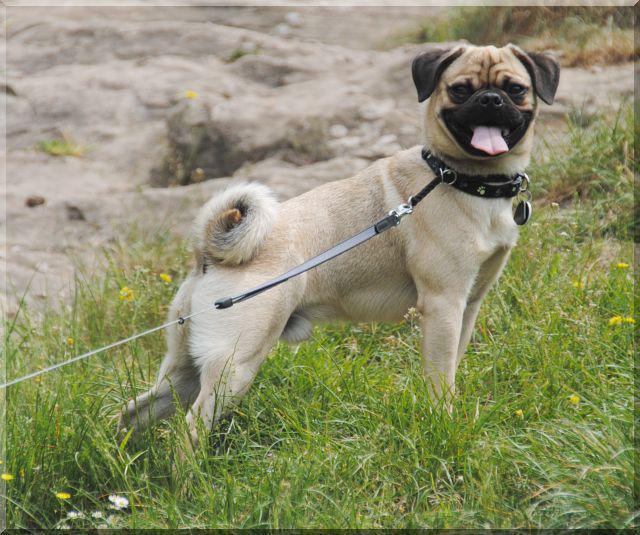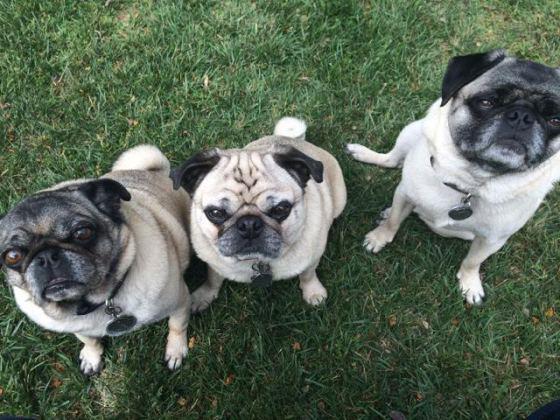The first image is the image on the left, the second image is the image on the right. Assess this claim about the two images: "Three buff-beige pugs are side-by-side on the grass in one image, and one dog standing and wearing a collar is in the other image.". Correct or not? Answer yes or no. Yes. The first image is the image on the left, the second image is the image on the right. Considering the images on both sides, is "The right image contains no more than one dog." valid? Answer yes or no. No. 